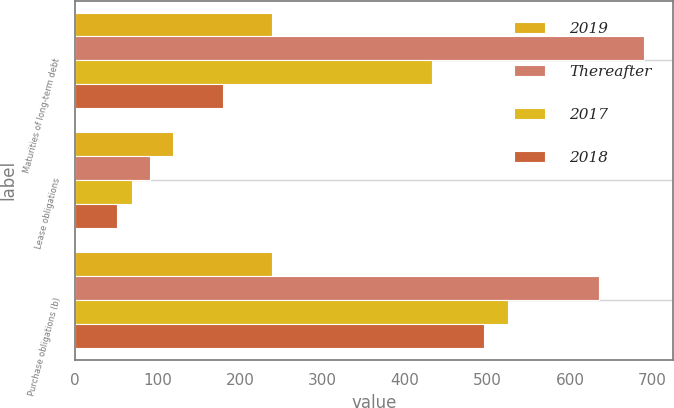<chart> <loc_0><loc_0><loc_500><loc_500><stacked_bar_chart><ecel><fcel>Maturities of long-term debt<fcel>Lease obligations<fcel>Purchase obligations (b)<nl><fcel>2019<fcel>239<fcel>119<fcel>239<nl><fcel>Thereafter<fcel>690<fcel>91<fcel>635<nl><fcel>2017<fcel>433<fcel>69<fcel>525<nl><fcel>2018<fcel>179<fcel>51<fcel>495<nl></chart> 